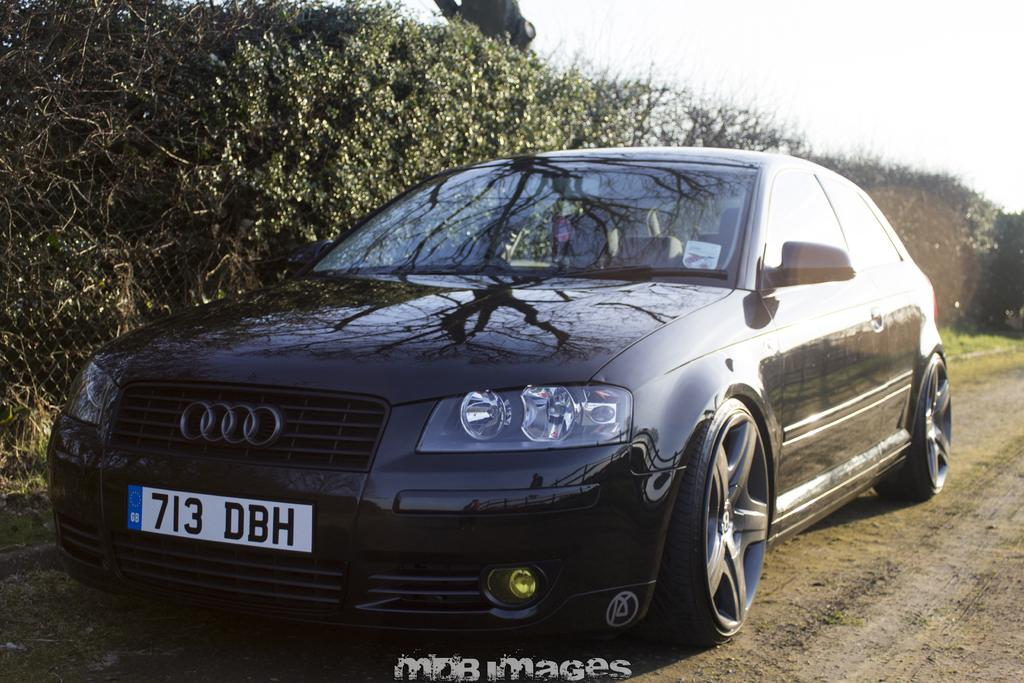What type of vehicle is in the image? There is a car in the image. What color is the car? The car is black in color. Where is the car located in the image? The car is on a sand road. What other objects or structures can be seen in the image? There is a fence in the image. What type of vegetation is visible in the image? There are trees in the left corner of the image. Reasoning: To produce the conversation, we first identify the main subject of the image, which is the car. We then describe its color and location, as well as any other objects or structures present in the image. We also mention the type of vegetation visible in the image. Absurd Question/Answer: How does the car provide comfort to its passengers in the image? The image does not provide information about the comfort level inside the car. 